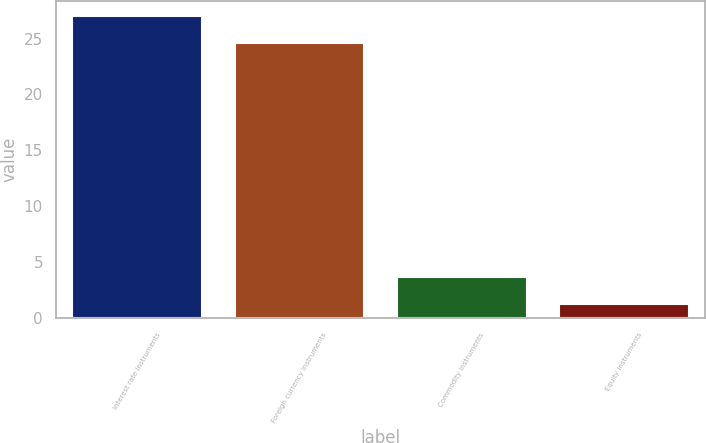<chart> <loc_0><loc_0><loc_500><loc_500><bar_chart><fcel>Interest rate instruments<fcel>Foreign currency instruments<fcel>Commodity instruments<fcel>Equity instruments<nl><fcel>26.98<fcel>24.6<fcel>3.68<fcel>1.3<nl></chart> 